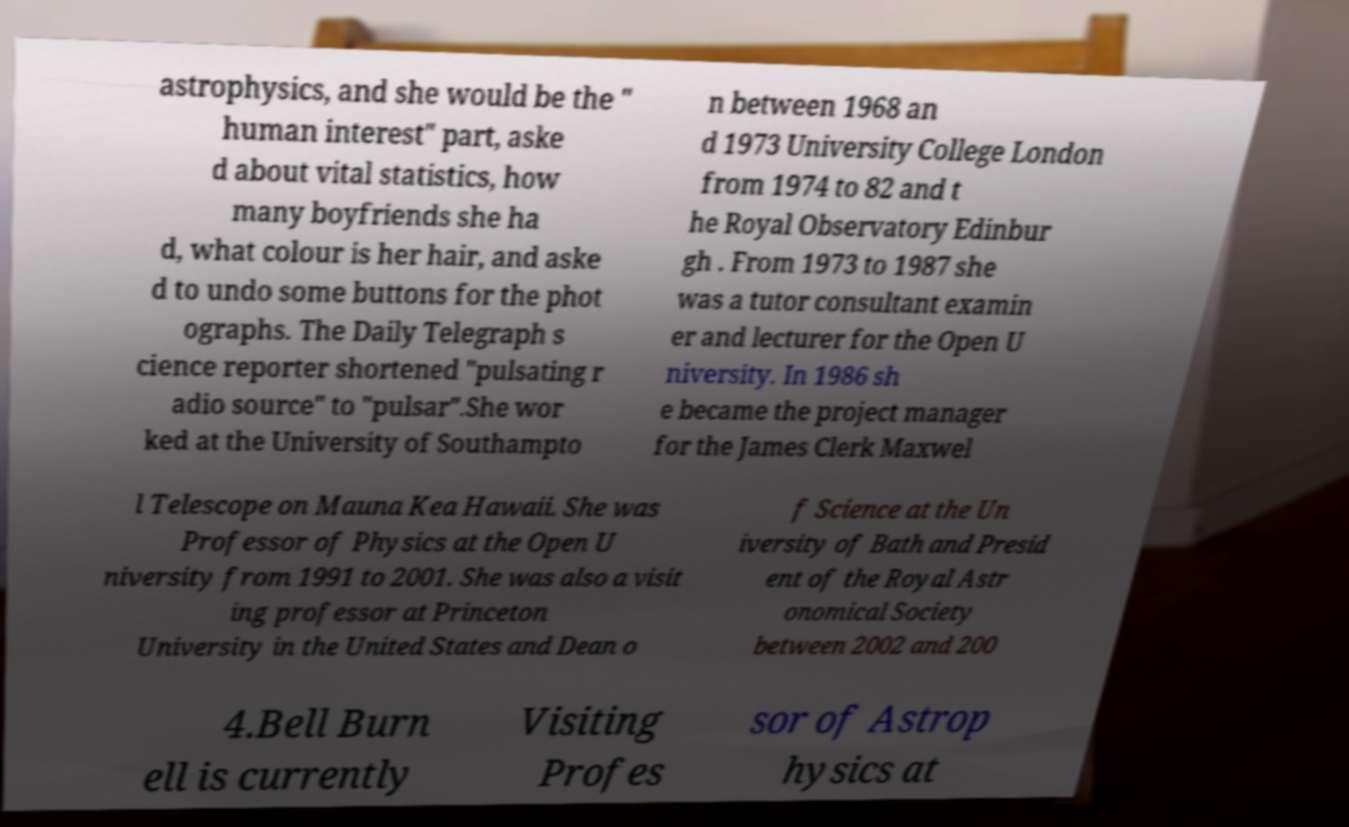Can you accurately transcribe the text from the provided image for me? astrophysics, and she would be the " human interest" part, aske d about vital statistics, how many boyfriends she ha d, what colour is her hair, and aske d to undo some buttons for the phot ographs. The Daily Telegraph s cience reporter shortened "pulsating r adio source" to "pulsar".She wor ked at the University of Southampto n between 1968 an d 1973 University College London from 1974 to 82 and t he Royal Observatory Edinbur gh . From 1973 to 1987 she was a tutor consultant examin er and lecturer for the Open U niversity. In 1986 sh e became the project manager for the James Clerk Maxwel l Telescope on Mauna Kea Hawaii. She was Professor of Physics at the Open U niversity from 1991 to 2001. She was also a visit ing professor at Princeton University in the United States and Dean o f Science at the Un iversity of Bath and Presid ent of the Royal Astr onomical Society between 2002 and 200 4.Bell Burn ell is currently Visiting Profes sor of Astrop hysics at 